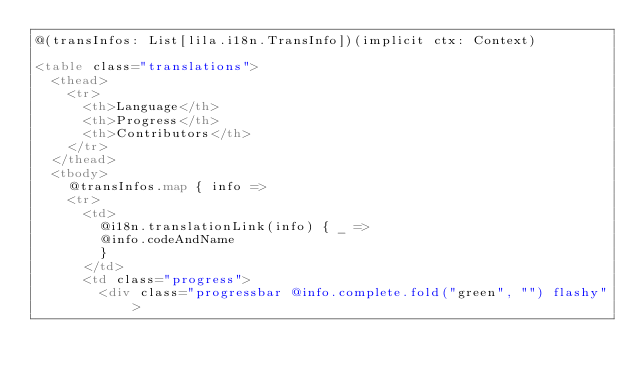Convert code to text. <code><loc_0><loc_0><loc_500><loc_500><_HTML_>@(transInfos: List[lila.i18n.TransInfo])(implicit ctx: Context)

<table class="translations">
  <thead>
    <tr>
      <th>Language</th>
      <th>Progress</th>
      <th>Contributors</th>
    </tr>
  </thead>
  <tbody>
    @transInfos.map { info =>
    <tr>
      <td>
        @i18n.translationLink(info) { _ => 
        @info.codeAndName
        }
      </td>
      <td class="progress">
        <div class="progressbar @info.complete.fold("green", "") flashy"></code> 